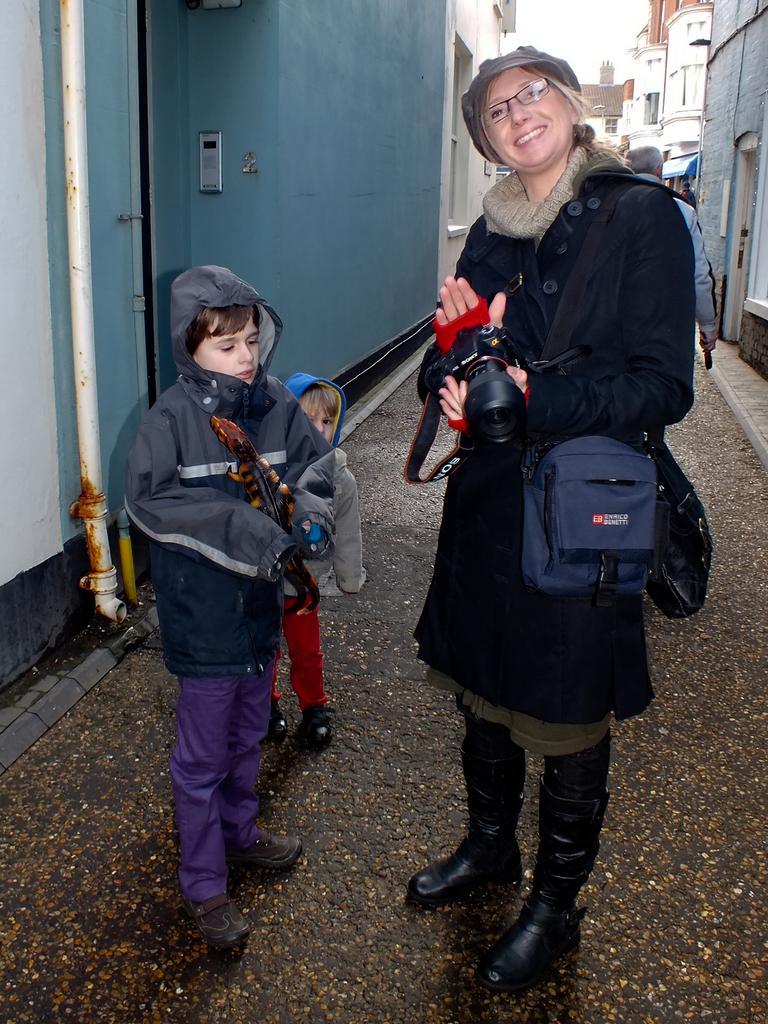In one or two sentences, can you explain what this image depicts? In the image we can see there are people who are standing on road and a woman is holding camera in her hand. 